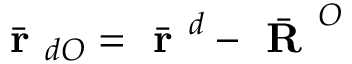<formula> <loc_0><loc_0><loc_500><loc_500>\bar { r } _ { d O } = \bar { r } ^ { d } - \bar { R } ^ { O }</formula> 